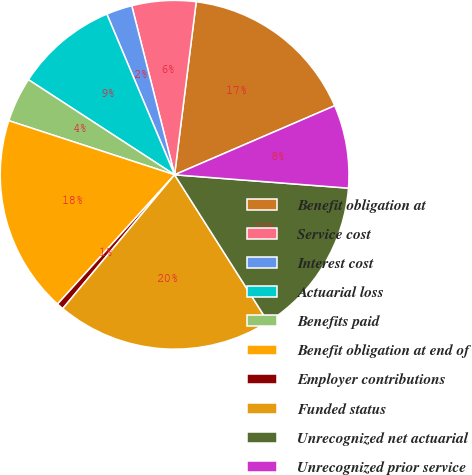Convert chart. <chart><loc_0><loc_0><loc_500><loc_500><pie_chart><fcel>Benefit obligation at<fcel>Service cost<fcel>Interest cost<fcel>Actuarial loss<fcel>Benefits paid<fcel>Benefit obligation at end of<fcel>Employer contributions<fcel>Funded status<fcel>Unrecognized net actuarial<fcel>Unrecognized prior service<nl><fcel>16.54%<fcel>5.93%<fcel>2.4%<fcel>9.47%<fcel>4.16%<fcel>18.31%<fcel>0.63%<fcel>20.08%<fcel>14.78%<fcel>7.7%<nl></chart> 